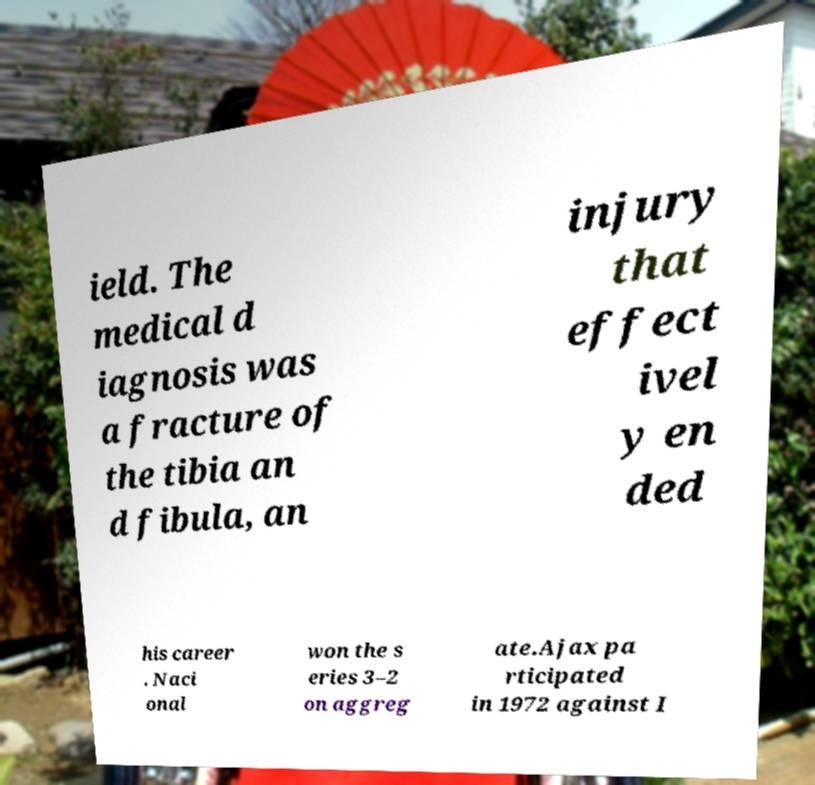I need the written content from this picture converted into text. Can you do that? ield. The medical d iagnosis was a fracture of the tibia an d fibula, an injury that effect ivel y en ded his career . Naci onal won the s eries 3–2 on aggreg ate.Ajax pa rticipated in 1972 against I 